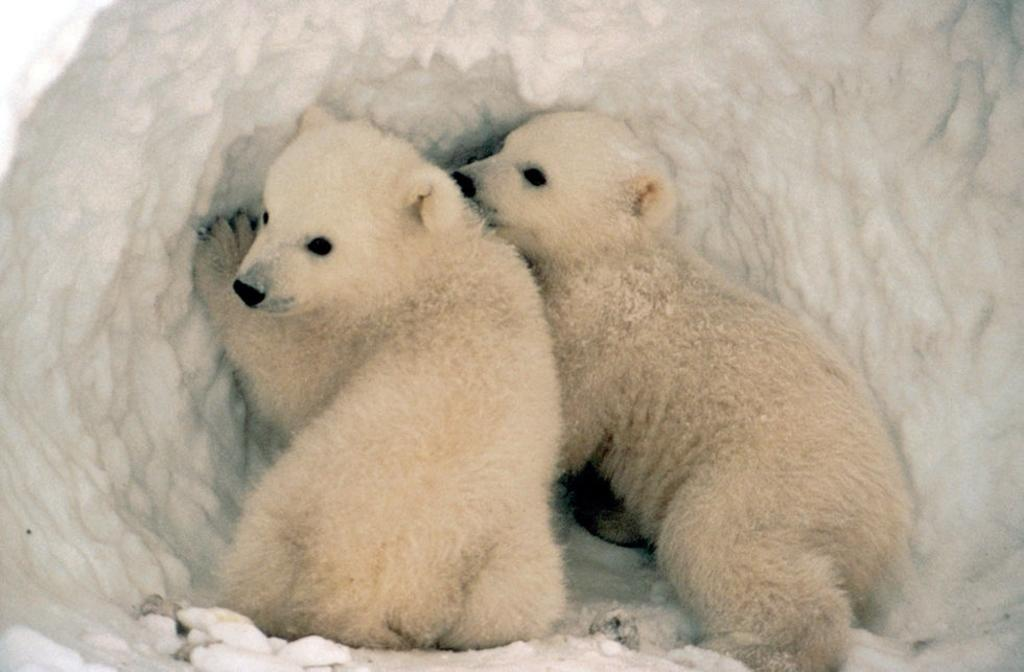How many polar bears are in the image? There are two polar bears in the image. Where are the polar bears located? The polar bears are present in the ice. What adjustment did the polar bears make to their living conditions in the image? There is no indication in the image of any adjustment made by the polar bears to their living conditions. 